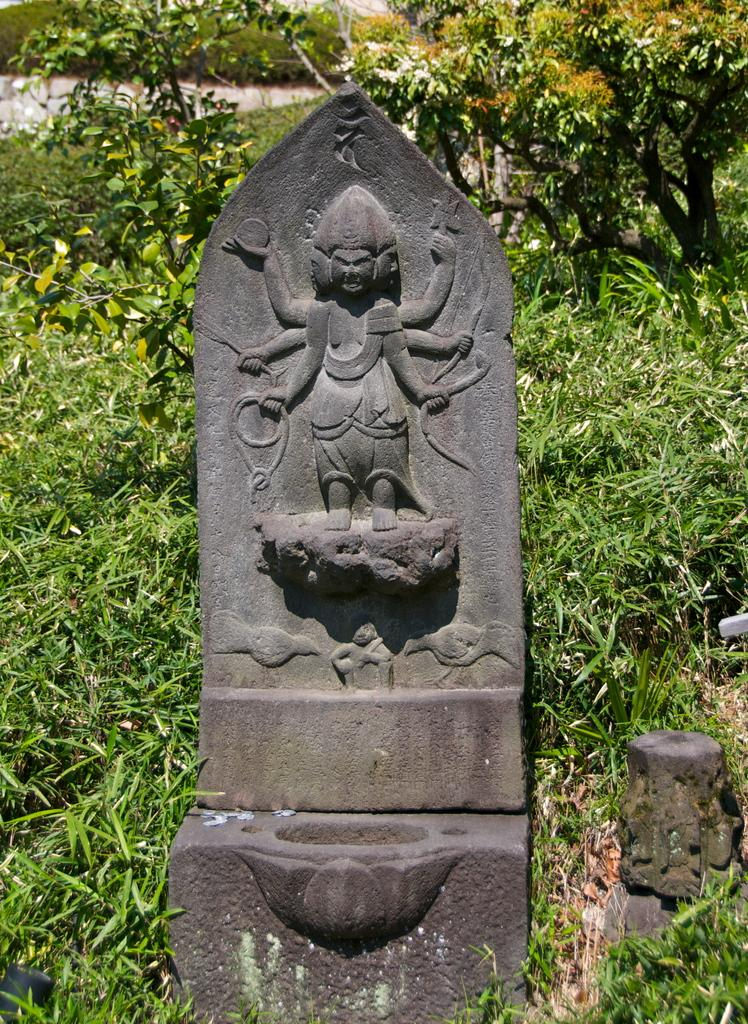What is depicted on the stone in the image? There are carvings on a stone in the image. What can be seen in the background of the image? There are plants in the background of the image. What type of impulse can be seen affecting the stone in the image? There is no impulse affecting the stone in the image; it is a static carving. What kind of bun is being used to hold the plants in the image? There is no bun present in the image; it features plants in the background. 